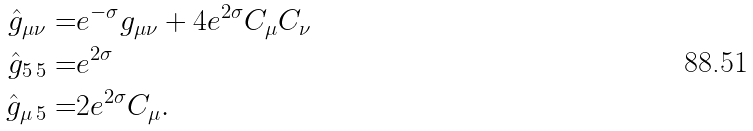Convert formula to latex. <formula><loc_0><loc_0><loc_500><loc_500>\hat { g } _ { \mu \nu } = & e ^ { - \sigma } g _ { \mu \nu } + 4 e ^ { 2 \sigma } C _ { \mu } C _ { \nu } \\ \hat { g } _ { 5 \, 5 } = & e ^ { 2 \sigma } \\ \hat { g } _ { \mu \, 5 } = & 2 e ^ { 2 \sigma } C _ { \mu } .</formula> 